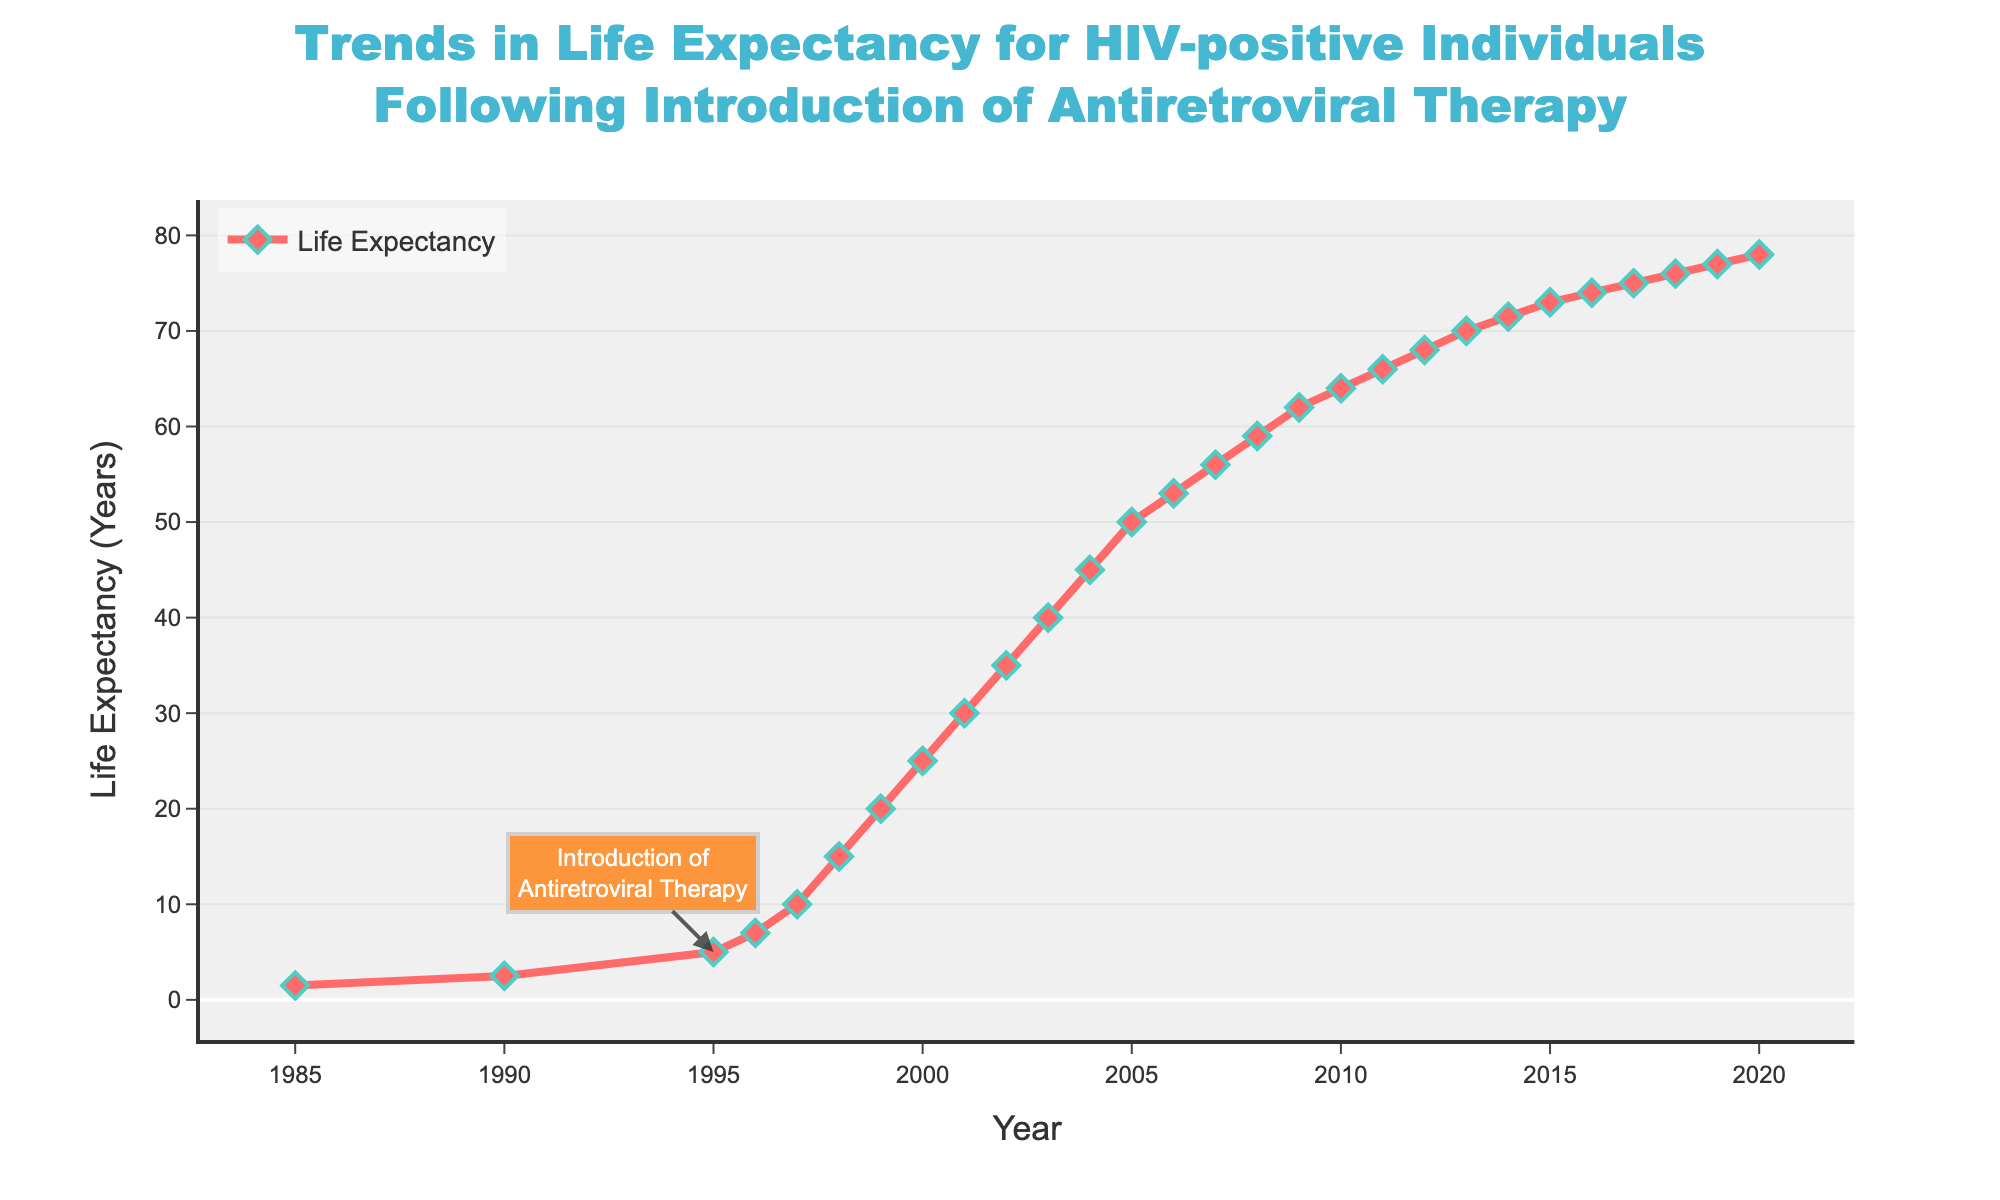what is the overall trend in life expectancy for HIV-positive individuals from 1985 to 2020? The figure shows that the life expectancy for HIV-positive individuals has consistently increased from 1985 to 2020. Specifically, it starts at 1.5 years in 1985 and reaches 78.0 years in 2020.
Answer: consistently increased what is the increase in life expectancy between 1985 and 1996, when the antiretroviral therapy was introduced? In 1985, the life expectancy was 1.5 years, and by 1996, it increased to 7.0 years. The increase is calculated by subtracting 1.5 from 7.0. 7.0 - 1.5 = 5.5.
Answer: 5.5 years how much did the life expectancy increase from 1996 to 2000? In 1996, life expectancy was 7.0 years and by 2000, it was 25.0 years. The increase is calculated by subtracting 7.0 from 25.0. 25.0 - 7.0 = 18.0.
Answer: 18.0 years what is the rate of increase in life expectancy between 2000 and 2005? In 2000, life expectancy was 25.0 years and in 2005, it was 50.0 years. The rate of increase can be calculated by finding the difference and dividing by the number of years (2005-2000 = 5). So, (50.0 - 25.0) / 5 = 5.0 years per year.
Answer: 5.0 years per year during which period was the increase in life expectancy most dramatic? By observing the plot, the increase in life expectancy appears most dramatic after the introduction of antiretroviral therapy in 1996, with significant jumps particularly between 1996 and 2000.
Answer: 1996 to 2000 which year saw the life expectancy surpass 50 years? The figure indicates that in 2005, life expectancy reached 50.0 years.
Answer: 2005 by how many years did life expectancy increase in the first decade after the introduction of antiretroviral therapy? In 1996, the life expectancy was 7.0 years. In 2006 (a decade later), it was 53.0 years. The increase is calculated by subtracting 7.0 from 53.0. 53.0 - 7.0 = 46.0.
Answer: 46.0 years how much did life expectancy increase between the beginning and the end of the data period, 1985 to 2020? In 1985, the life expectancy was 1.5 years. By 2020, it increased to 78.0 years. The increase is calculated by subtracting 1.5 from 78.0. 78.0 - 1.5 = 76.5.
Answer: 76.5 years 